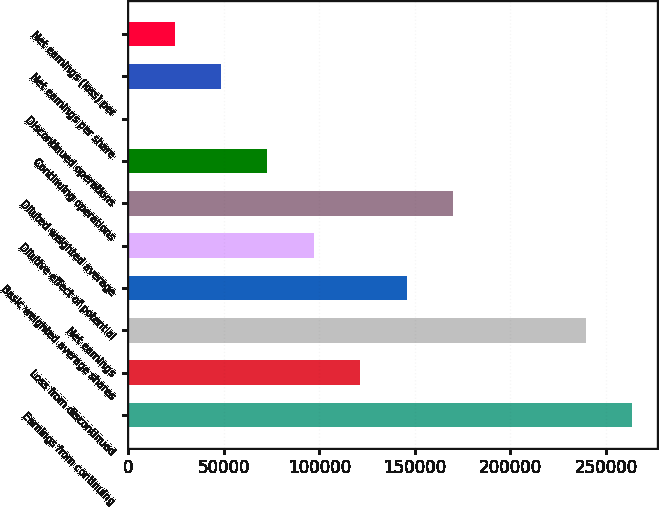<chart> <loc_0><loc_0><loc_500><loc_500><bar_chart><fcel>Earnings from continuing<fcel>Loss from discontinued<fcel>Net earnings<fcel>Basic weighted average shares<fcel>Dilutive effect of potential<fcel>Diluted weighted average<fcel>Continuing operations<fcel>Discontinued operations<fcel>Net earnings per share<fcel>Net earnings (loss) per<nl><fcel>263748<fcel>121458<fcel>239456<fcel>145750<fcel>97166.4<fcel>170041<fcel>72874.8<fcel>0.03<fcel>48583.2<fcel>24291.6<nl></chart> 